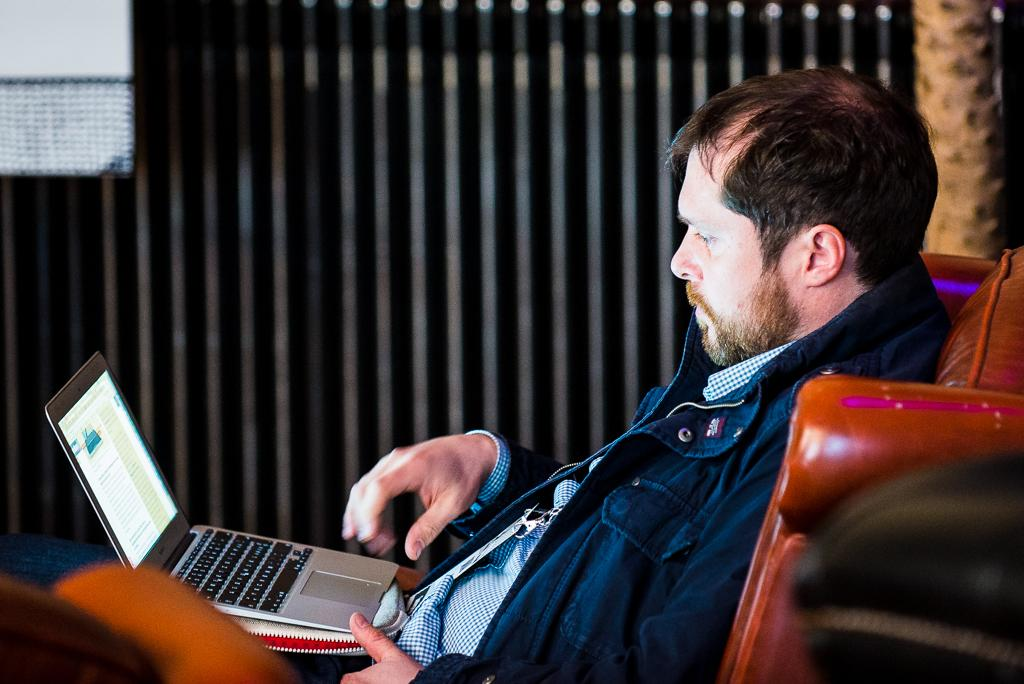What is the person in the image doing? The person is sitting on a chair and working on a laptop. What can be seen behind the person in the image? There is a wall in the background of the image. How is the background of the image depicted? The background of the image is blurred. How many sticks of butter are on the table next to the person in the image? There is no butter present in the image. What type of women are visible in the image? There are no women visible in the image; only one person is present. Is there a fireman in the image? No, there is no fireman present in the image. 